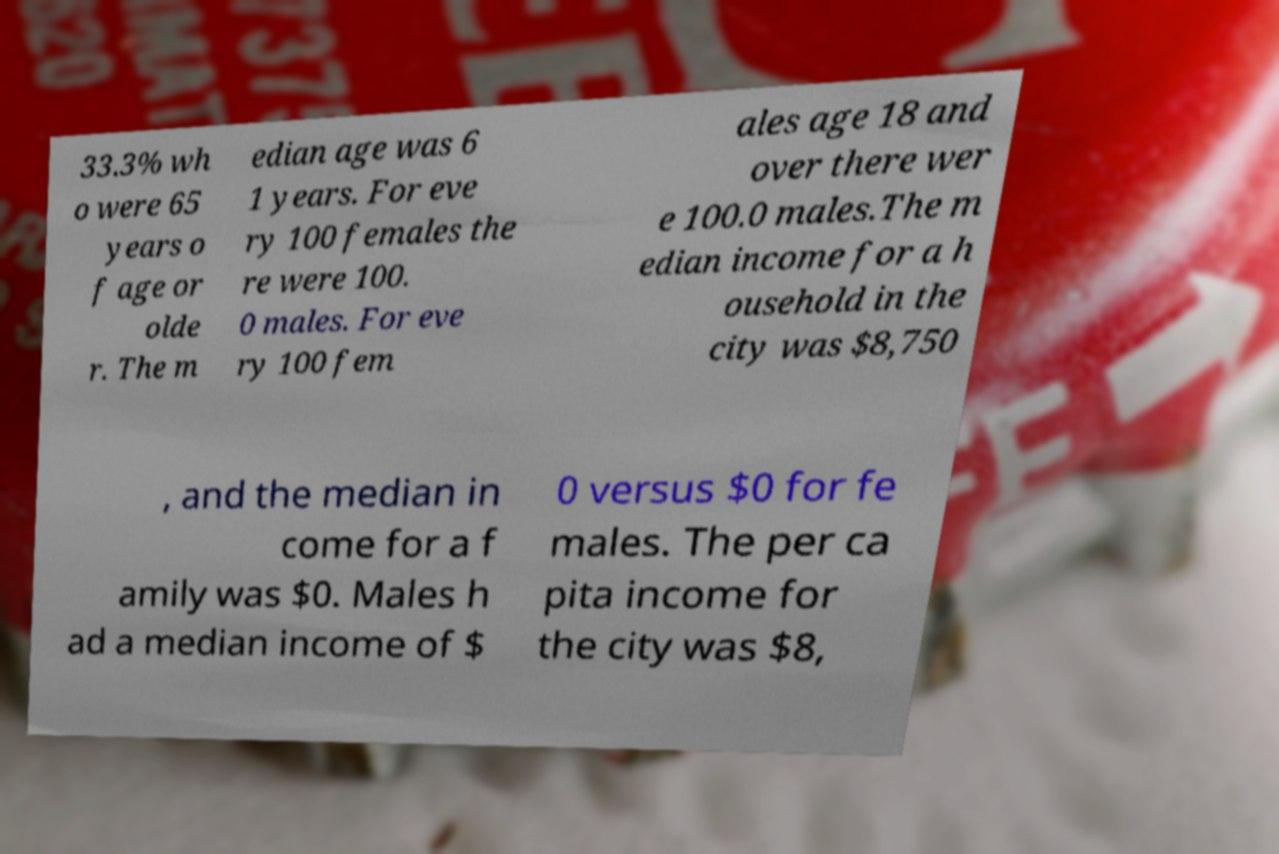Can you accurately transcribe the text from the provided image for me? 33.3% wh o were 65 years o f age or olde r. The m edian age was 6 1 years. For eve ry 100 females the re were 100. 0 males. For eve ry 100 fem ales age 18 and over there wer e 100.0 males.The m edian income for a h ousehold in the city was $8,750 , and the median in come for a f amily was $0. Males h ad a median income of $ 0 versus $0 for fe males. The per ca pita income for the city was $8, 